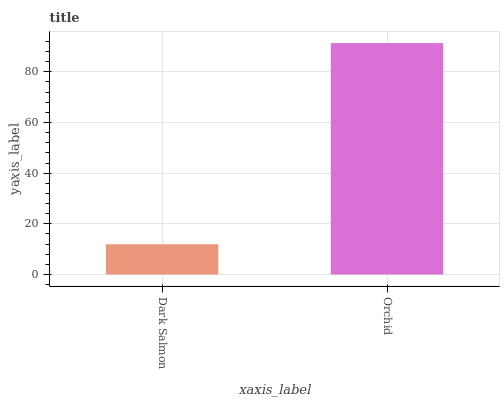Is Dark Salmon the minimum?
Answer yes or no. Yes. Is Orchid the maximum?
Answer yes or no. Yes. Is Orchid the minimum?
Answer yes or no. No. Is Orchid greater than Dark Salmon?
Answer yes or no. Yes. Is Dark Salmon less than Orchid?
Answer yes or no. Yes. Is Dark Salmon greater than Orchid?
Answer yes or no. No. Is Orchid less than Dark Salmon?
Answer yes or no. No. Is Orchid the high median?
Answer yes or no. Yes. Is Dark Salmon the low median?
Answer yes or no. Yes. Is Dark Salmon the high median?
Answer yes or no. No. Is Orchid the low median?
Answer yes or no. No. 